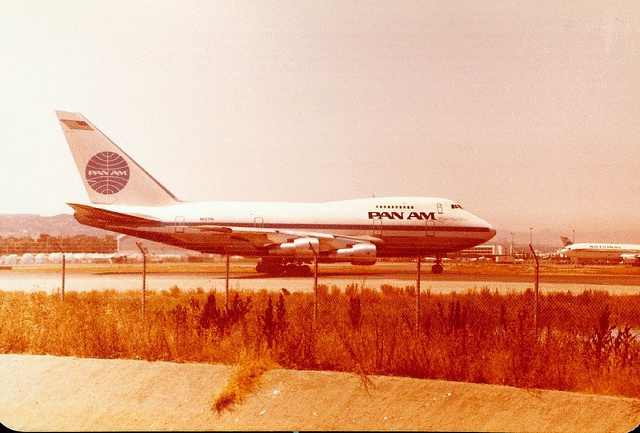Describe the objects in this image and their specific colors. I can see airplane in ivory, maroon, and tan tones and airplane in ivory, red, beige, and tan tones in this image. 